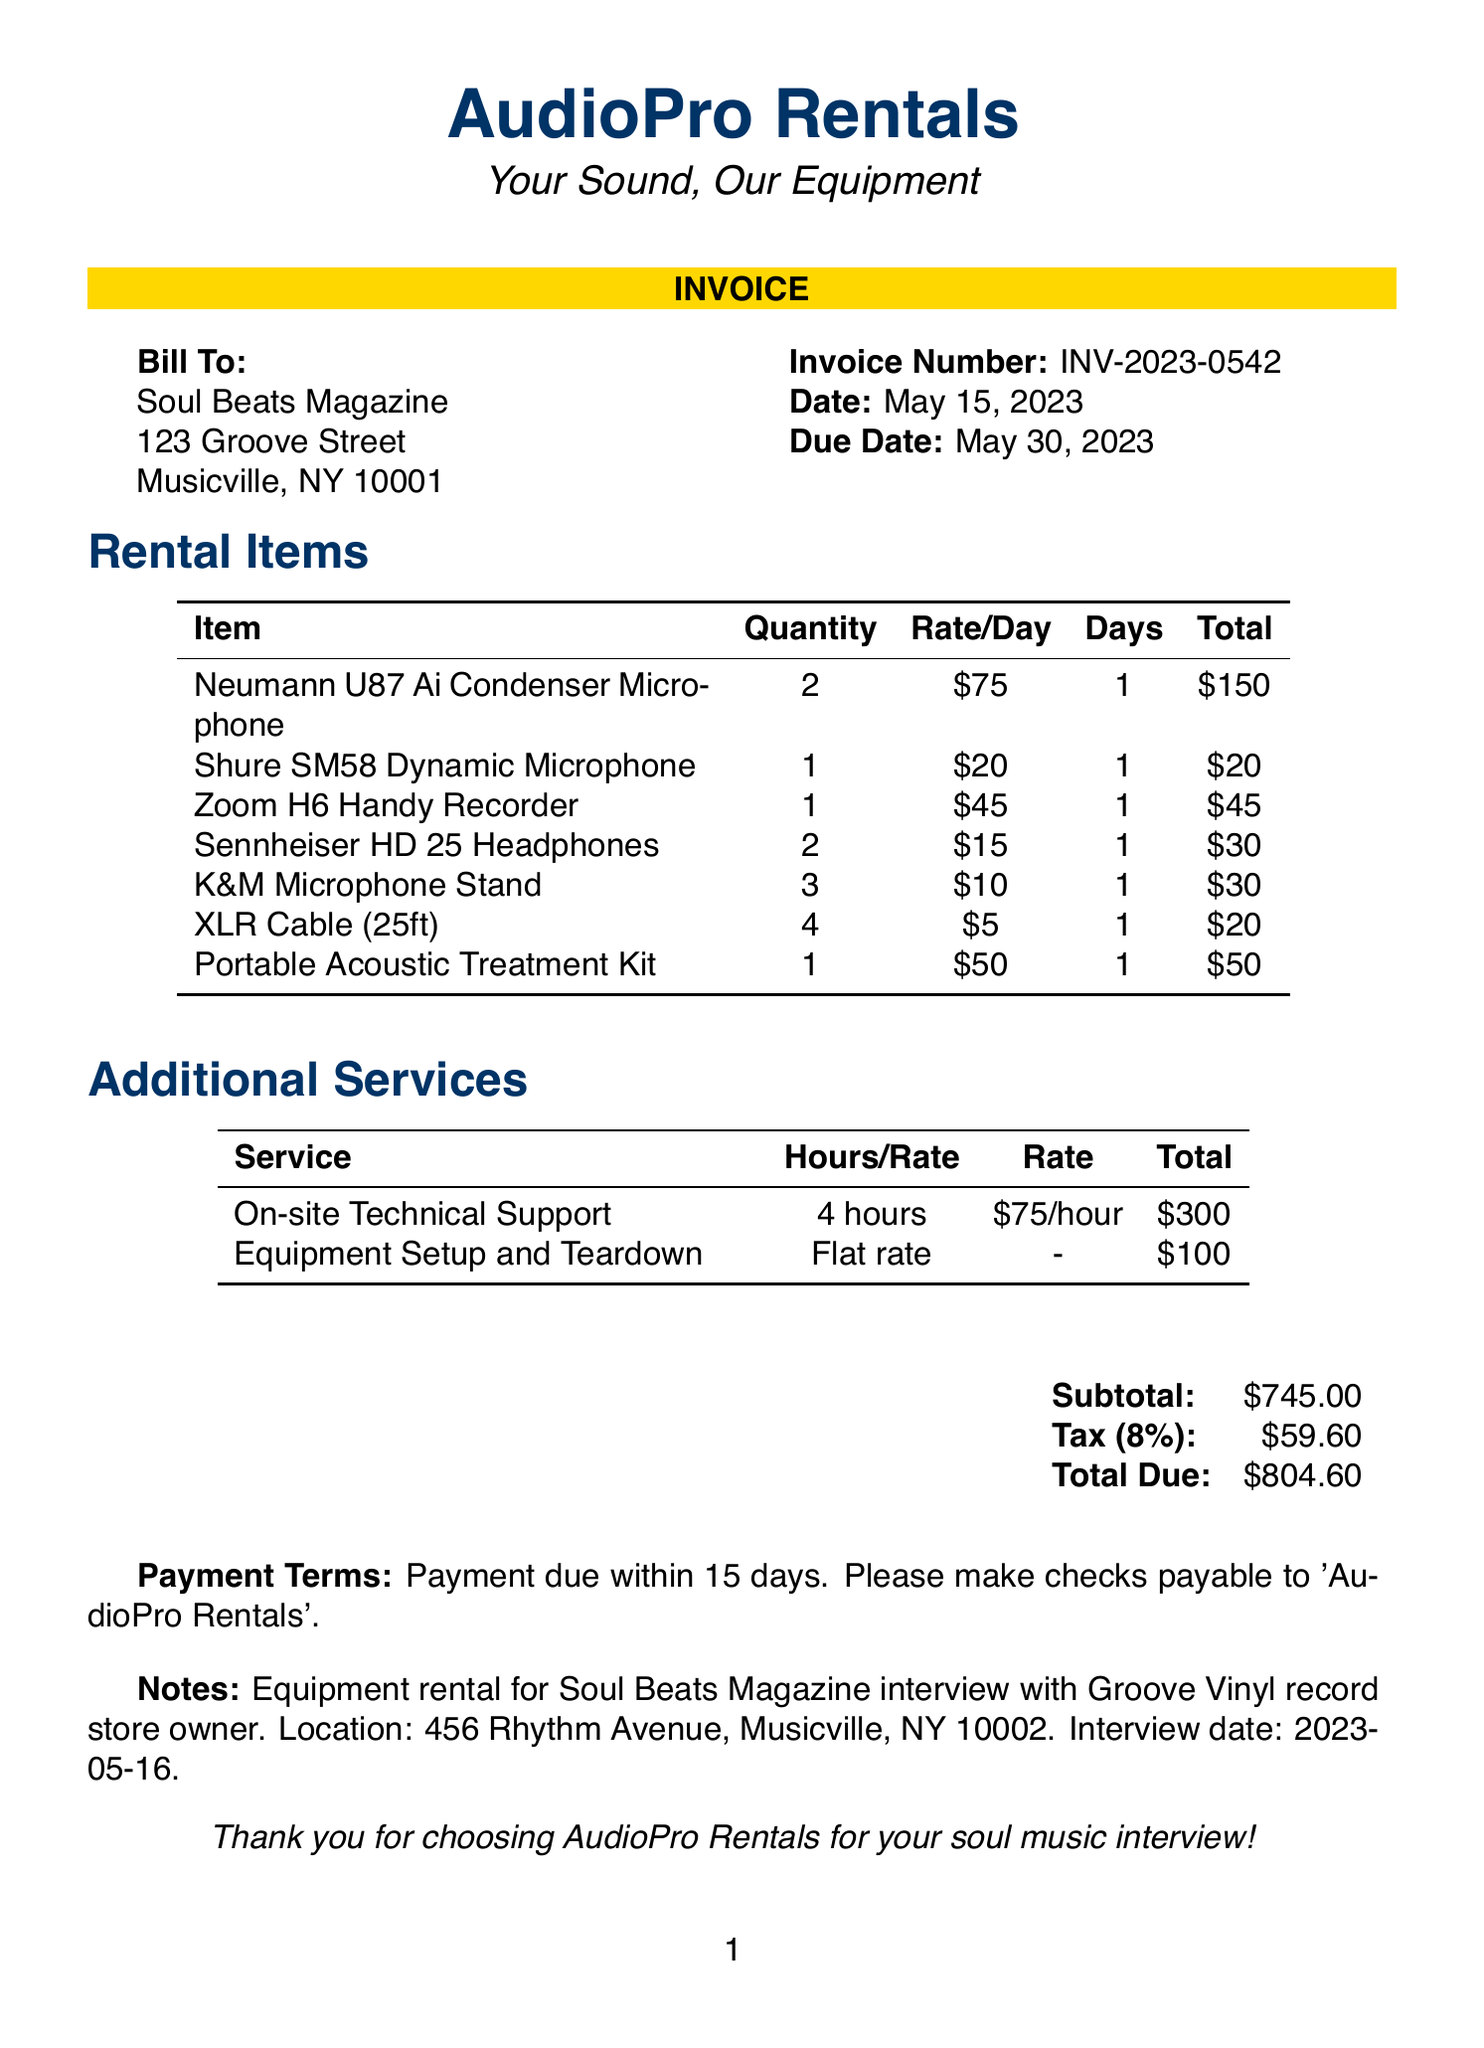what is the invoice number? The invoice number is clearly listed at the top of the document as INV-2023-0542.
Answer: INV-2023-0542 what is the date of the invoice? The date of the invoice is specified right after the invoice number as May 15, 2023.
Answer: May 15, 2023 how many Neumann U87 Ai microphones were rented? The quantity of Neumann U87 Ai Condenser Microphones rented is listed in the rental items section as 2.
Answer: 2 what was the total due amount? The total due amount is located in the summary section at the bottom of the document as $804.60.
Answer: $804.60 how much was charged for On-site Technical Support? The charge for On-site Technical Support is mentioned in the additional services section as $300.
Answer: $300 what is the tax rate applied in this invoice? The tax rate is clearly indicated in the summary section as 8%.
Answer: 8% what service has a flat rate charge? The document specifies that Equipment Setup and Teardown is offered as a flat rate service charge.
Answer: Equipment Setup and Teardown what is the due date for the invoice? The due date for the invoice is provided right under the date as May 30, 2023.
Answer: May 30, 2023 where was the equipment rented for? The rental location is detailed in the notes section as 456 Rhythm Avenue, Musicville, NY 10002.
Answer: 456 Rhythm Avenue, Musicville, NY 10002 